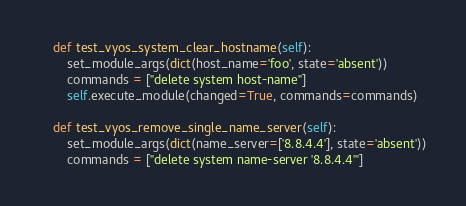Convert code to text. <code><loc_0><loc_0><loc_500><loc_500><_Python_>    def test_vyos_system_clear_hostname(self):
        set_module_args(dict(host_name='foo', state='absent'))
        commands = ["delete system host-name"]
        self.execute_module(changed=True, commands=commands)

    def test_vyos_remove_single_name_server(self):
        set_module_args(dict(name_server=['8.8.4.4'], state='absent'))
        commands = ["delete system name-server '8.8.4.4'"]</code> 